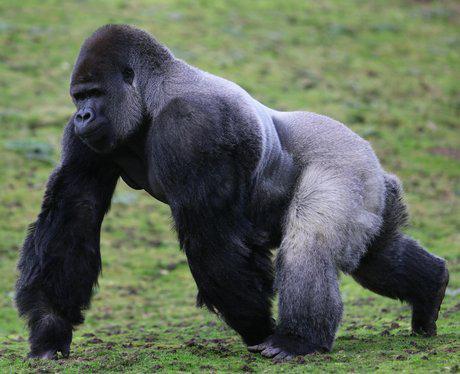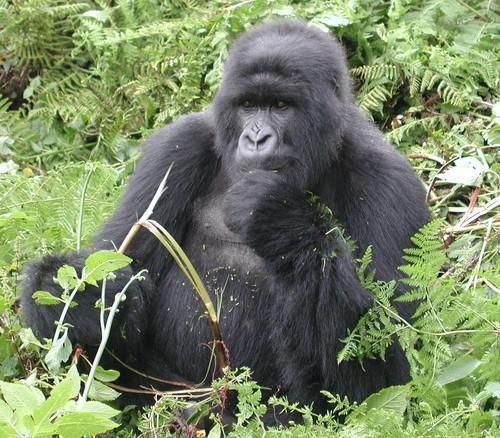The first image is the image on the left, the second image is the image on the right. Examine the images to the left and right. Is the description "In one of the images there is a baby gorilla near at least one adult gorilla." accurate? Answer yes or no. No. The first image is the image on the left, the second image is the image on the right. For the images displayed, is the sentence "At least one images contains a very young gorilla." factually correct? Answer yes or no. No. The first image is the image on the left, the second image is the image on the right. Considering the images on both sides, is "There are no more than three gorillas" valid? Answer yes or no. Yes. 